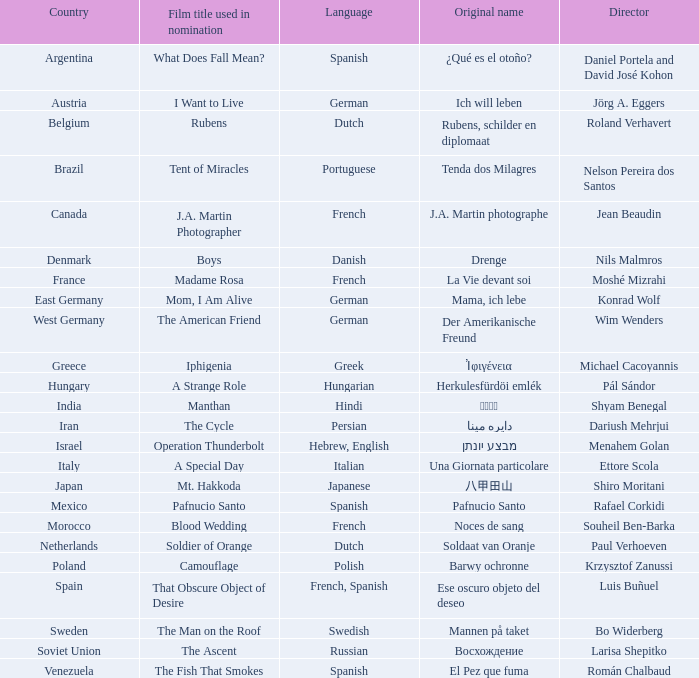From which country does the director roland verhavert hail? Belgium. 